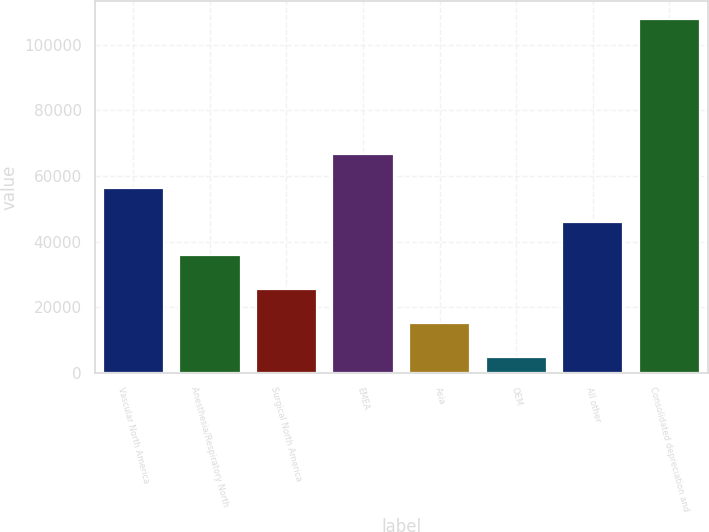Convert chart to OTSL. <chart><loc_0><loc_0><loc_500><loc_500><bar_chart><fcel>Vascular North America<fcel>Anesthesia/Respiratory North<fcel>Surgical North America<fcel>EMEA<fcel>Asia<fcel>OEM<fcel>All other<fcel>Consolidated depreciation and<nl><fcel>56405.5<fcel>35793.7<fcel>25487.8<fcel>66711.4<fcel>15181.9<fcel>4876<fcel>46099.6<fcel>107935<nl></chart> 